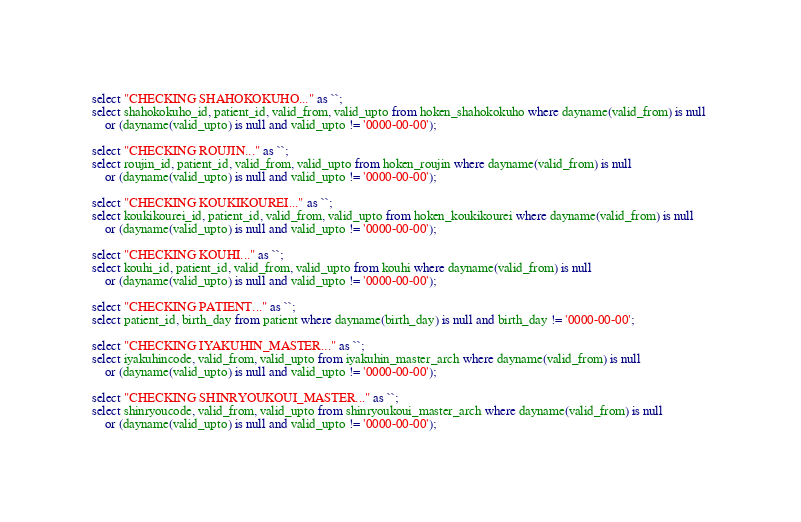Convert code to text. <code><loc_0><loc_0><loc_500><loc_500><_SQL_>select "CHECKING SHAHOKOKUHO..." as ``;
select shahokokuho_id, patient_id, valid_from, valid_upto from hoken_shahokokuho where dayname(valid_from) is null 
	or (dayname(valid_upto) is null and valid_upto != '0000-00-00');

select "CHECKING ROUJIN..." as ``;
select roujin_id, patient_id, valid_from, valid_upto from hoken_roujin where dayname(valid_from) is null 
	or (dayname(valid_upto) is null and valid_upto != '0000-00-00');

select "CHECKING KOUKIKOUREI..." as ``;
select koukikourei_id, patient_id, valid_from, valid_upto from hoken_koukikourei where dayname(valid_from) is null 
	or (dayname(valid_upto) is null and valid_upto != '0000-00-00');

select "CHECKING KOUHI..." as ``;
select kouhi_id, patient_id, valid_from, valid_upto from kouhi where dayname(valid_from) is null 
	or (dayname(valid_upto) is null and valid_upto != '0000-00-00');

select "CHECKING PATIENT..." as ``;
select patient_id, birth_day from patient where dayname(birth_day) is null and birth_day != '0000-00-00';

select "CHECKING IYAKUHIN_MASTER..." as ``;
select iyakuhincode, valid_from, valid_upto from iyakuhin_master_arch where dayname(valid_from) is null 
	or (dayname(valid_upto) is null and valid_upto != '0000-00-00');

select "CHECKING SHINRYOUKOUI_MASTER..." as ``;
select shinryoucode, valid_from, valid_upto from shinryoukoui_master_arch where dayname(valid_from) is null 
	or (dayname(valid_upto) is null and valid_upto != '0000-00-00');
</code> 